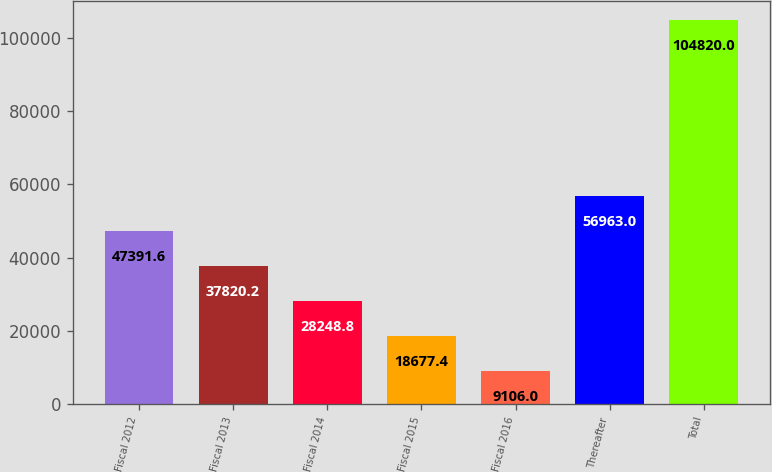<chart> <loc_0><loc_0><loc_500><loc_500><bar_chart><fcel>Fiscal 2012<fcel>Fiscal 2013<fcel>Fiscal 2014<fcel>Fiscal 2015<fcel>Fiscal 2016<fcel>Thereafter<fcel>Total<nl><fcel>47391.6<fcel>37820.2<fcel>28248.8<fcel>18677.4<fcel>9106<fcel>56963<fcel>104820<nl></chart> 